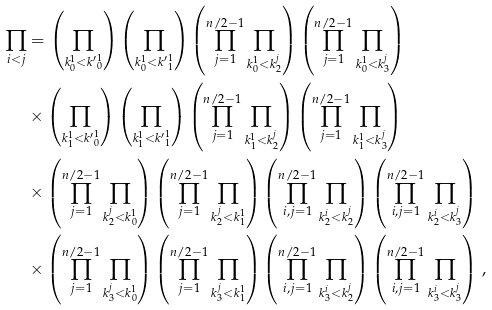Convert formula to latex. <formula><loc_0><loc_0><loc_500><loc_500>\prod _ { i < j } & = \left ( \prod _ { k _ { 0 } ^ { 1 } < { k ^ { \prime } } _ { 0 } ^ { 1 } } \right ) \left ( \prod _ { k _ { 0 } ^ { 1 } < { k ^ { \prime } } _ { 1 } ^ { 1 } } \right ) \left ( \prod _ { j = 1 } ^ { n / 2 - 1 } \prod _ { k _ { 0 } ^ { 1 } < k _ { 2 } ^ { j } } \right ) \left ( \prod _ { j = 1 } ^ { n / 2 - 1 } \prod _ { k _ { 0 } ^ { 1 } < k _ { 3 } ^ { j } } \right ) \\ & \times \left ( \prod _ { k _ { 1 } ^ { 1 } < { k ^ { \prime } } _ { 0 } ^ { 1 } } \right ) \left ( \prod _ { k _ { 1 } ^ { 1 } < { k ^ { \prime } } _ { 1 } ^ { 1 } } \right ) \left ( \prod _ { j = 1 } ^ { n / 2 - 1 } \prod _ { k _ { 1 } ^ { 1 } < k _ { 2 } ^ { j } } \right ) \left ( \prod _ { j = 1 } ^ { n / 2 - 1 } \prod _ { k _ { 1 } ^ { 1 } < k _ { 3 } ^ { j } } \right ) \\ & \times \left ( \prod _ { j = 1 } ^ { n / 2 - 1 } \prod _ { k ^ { j } _ { 2 } < k _ { 0 } ^ { 1 } } \right ) \left ( \prod _ { j = 1 } ^ { n / 2 - 1 } \prod _ { k ^ { j } _ { 2 } < k _ { 1 } ^ { 1 } } \right ) \left ( \prod _ { i , j = 1 } ^ { n / 2 - 1 } \prod _ { k ^ { i } _ { 2 } < k _ { 2 } ^ { j } } \right ) \left ( \prod _ { i , j = 1 } ^ { n / 2 - 1 } \prod _ { k ^ { i } _ { 2 } < k _ { 3 } ^ { j } } \right ) \\ & \times \left ( \prod _ { j = 1 } ^ { n / 2 - 1 } \prod _ { k ^ { j } _ { 3 } < k _ { 0 } ^ { 1 } } \right ) \left ( \prod _ { j = 1 } ^ { n / 2 - 1 } \prod _ { k ^ { j } _ { 3 } < k _ { 1 } ^ { 1 } } \right ) \left ( \prod _ { i , j = 1 } ^ { n / 2 - 1 } \prod _ { k ^ { i } _ { 3 } < k _ { 2 } ^ { j } } \right ) \left ( \prod _ { i , j = 1 } ^ { n / 2 - 1 } \prod _ { k ^ { i } _ { 3 } < k _ { 3 } ^ { j } } \right ) \, , \\</formula> 